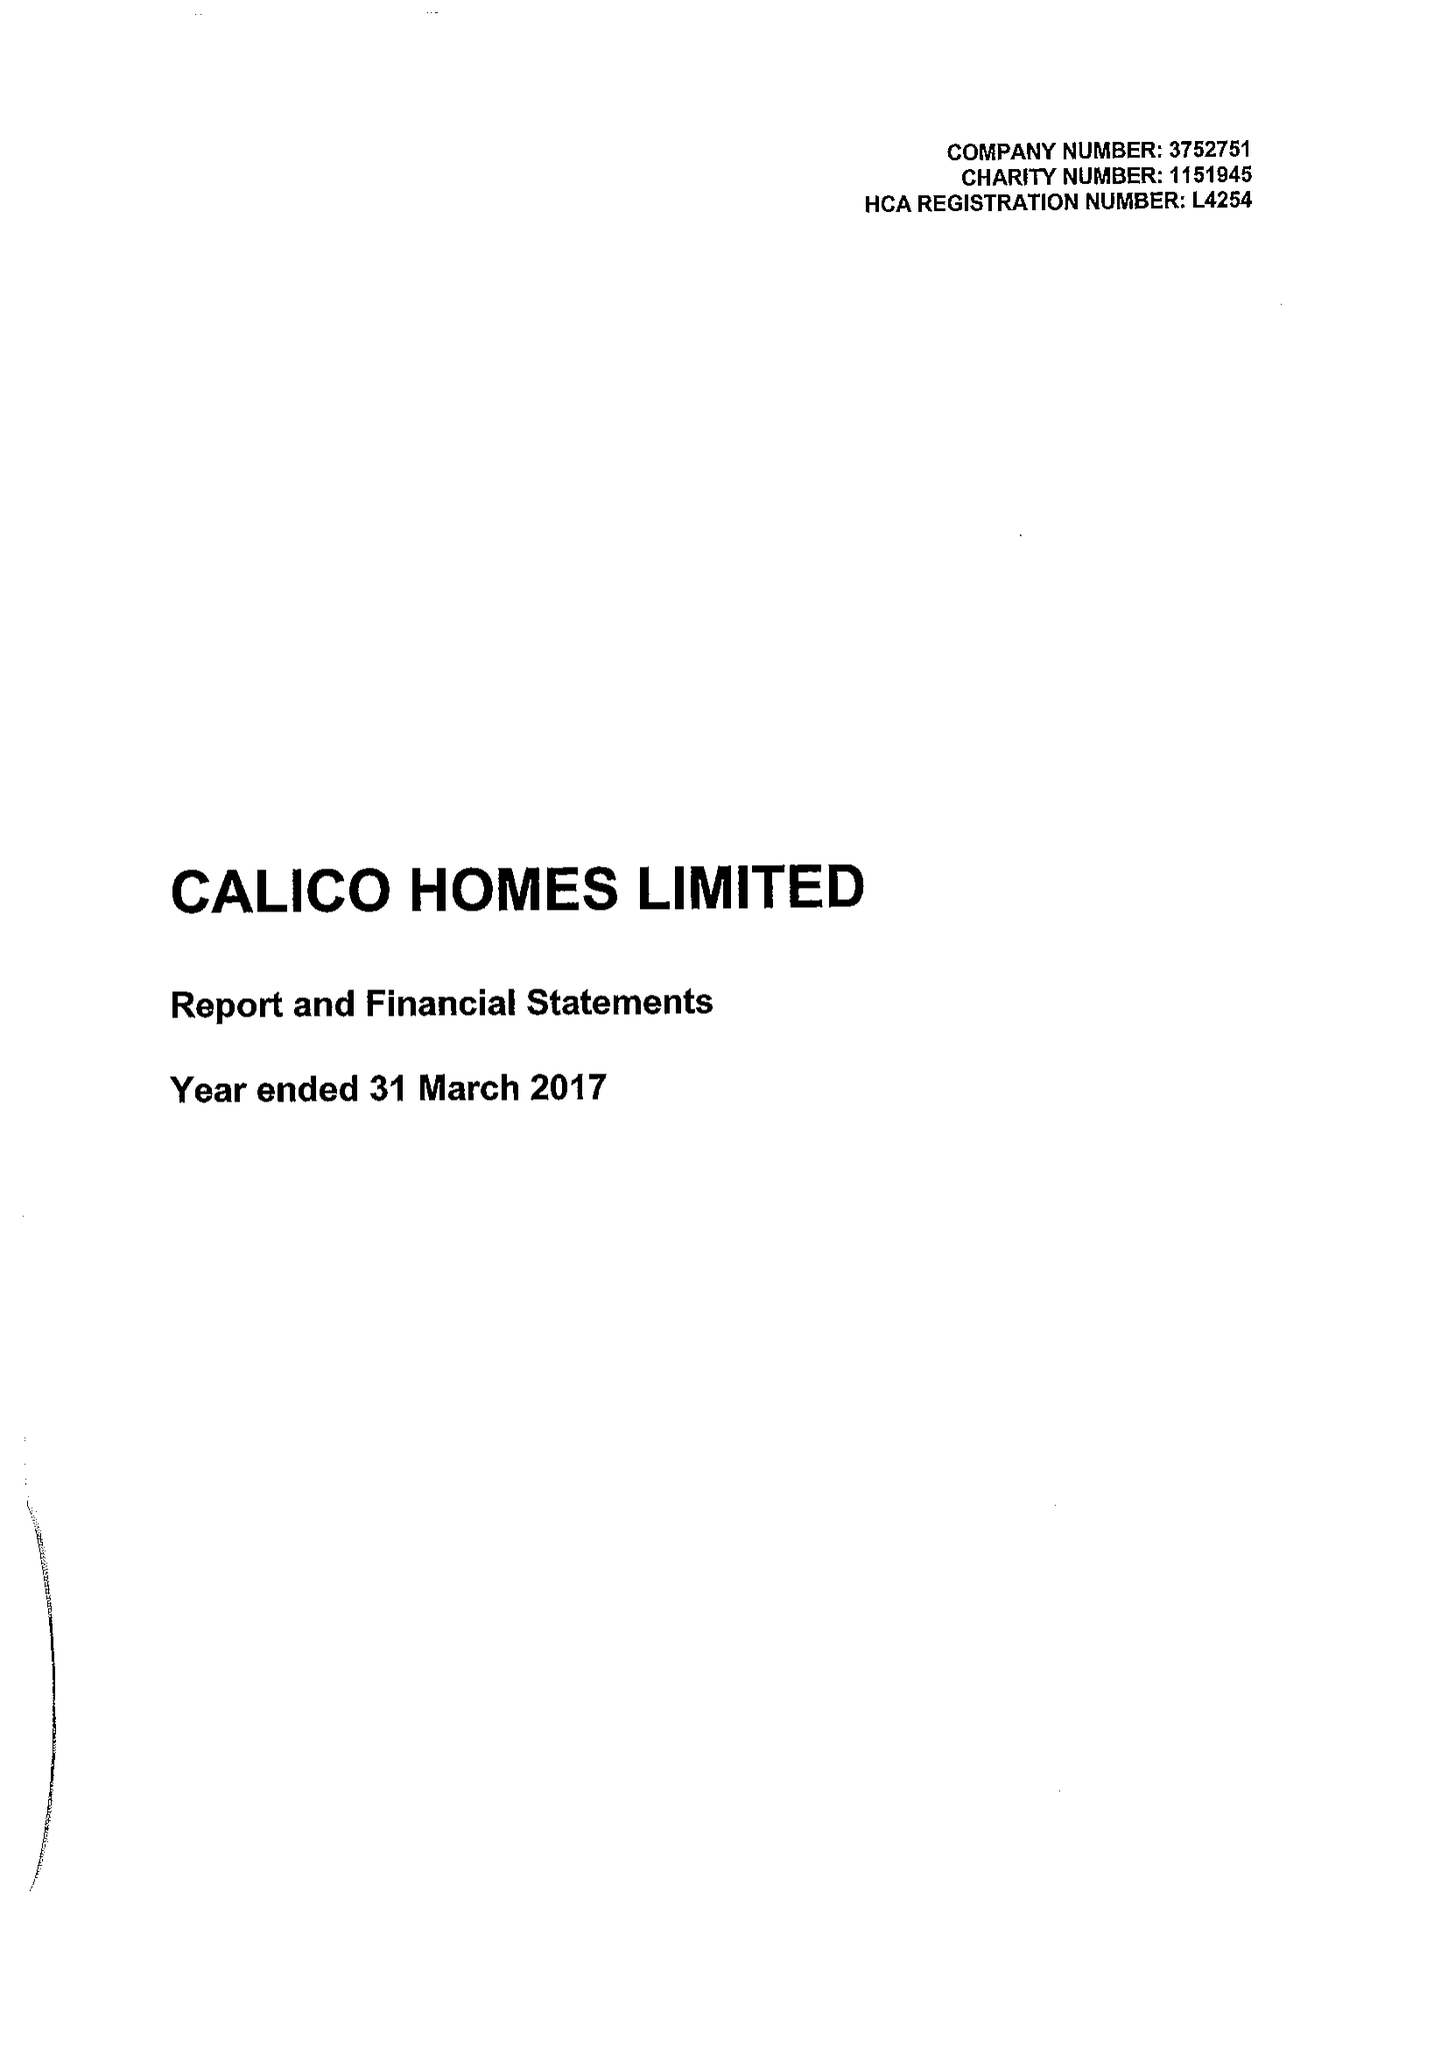What is the value for the address__street_line?
Answer the question using a single word or phrase. CROFT STREET 